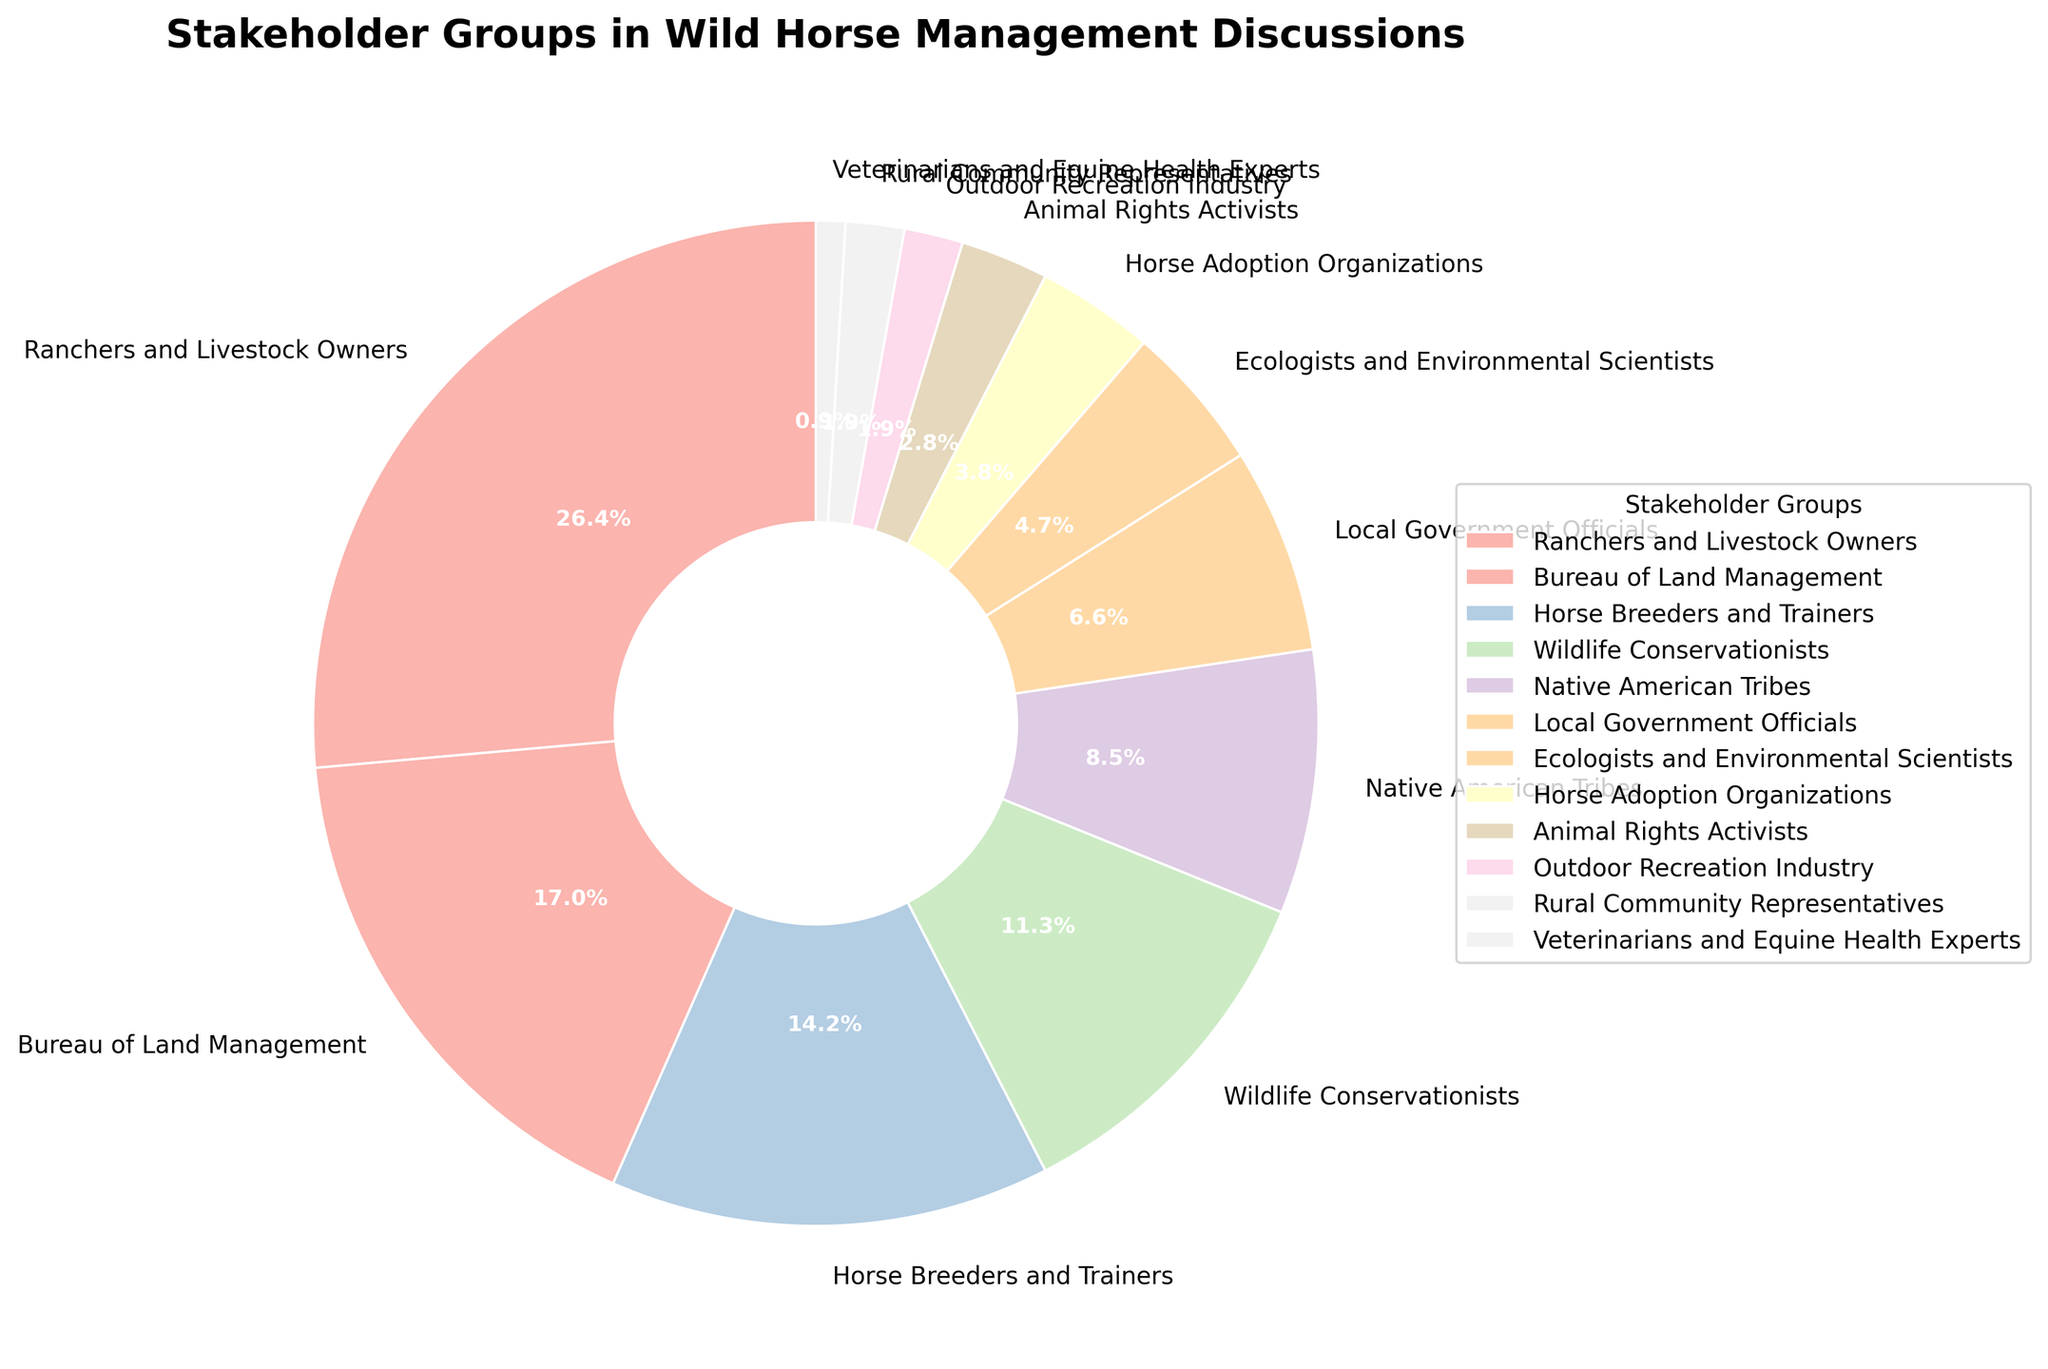Which stakeholder group has the highest percentage? By looking at the pie chart, the segment with the largest slice represents the group with the highest percentage. In this case, it's the Ranchers and Livestock Owners.
Answer: Ranchers and Livestock Owners What is the total percentage for the top three groups? To find the total percentage for the top three groups, identify the top three segments in the pie chart and sum their percentages: Ranchers and Livestock Owners (28%) + Bureau of Land Management (18%) + Horse Breeders and Trainers (15%) = 61%.
Answer: 61% Which group has a higher percentage, Ecologists and Environmental Scientists or Native American Tribes? By comparing the respective segments, we see that Native American Tribes (9%) is higher than Ecologists and Environmental Scientists (5%).
Answer: Native American Tribes How much larger is the percentage of Wildlife Conservationists compared to the percentage of Horse Adoption Organizations? The percentage of Wildlife Conservationists is 12%, and Horse Adoption Organizations is 4%. The difference is 12% - 4% = 8%.
Answer: 8% Which groups have segments in visually similar colors? By examining the segments of the pie chart, one can identify the groups with visually similar colors like pastel shades. For example, Animal Rights Activists and Outdoor Recreation Industry segments might share a similar visual color since both are in light pastel colors.
Answer: Animal Rights Activists and Outdoor Recreation Industry What is the combined percentage for all groups that have a percentage less than 5%? Identify and sum the percentages of the groups with less than 5%: Horse Adoption Organizations (4%) + Animal Rights Activists (3%) + Outdoor Recreation Industry (2%) + Rural Community Representatives (2%) + Veterinarians and Equine Health Experts (1%) = 12%.
Answer: 12% Are there more groups with percentages above or below 5%? Count the number of groups above 5% and below 5%. Groups above 5%: 7 (Ranchers and Livestock Owners, Bureau of Land Management, Horse Breeders and Trainers, Wildlife Conservationists, Native American Tribes, Local Government Officials, Ecologists and Environmental Scientists). Groups below 5%: 5 (Horse Adoption Organizations, Animal Rights Activists, Outdoor Recreation Industry, Rural Community Representatives, Veterinarians and Equine Health Experts). So, there are more groups above 5%.
Answer: Above 